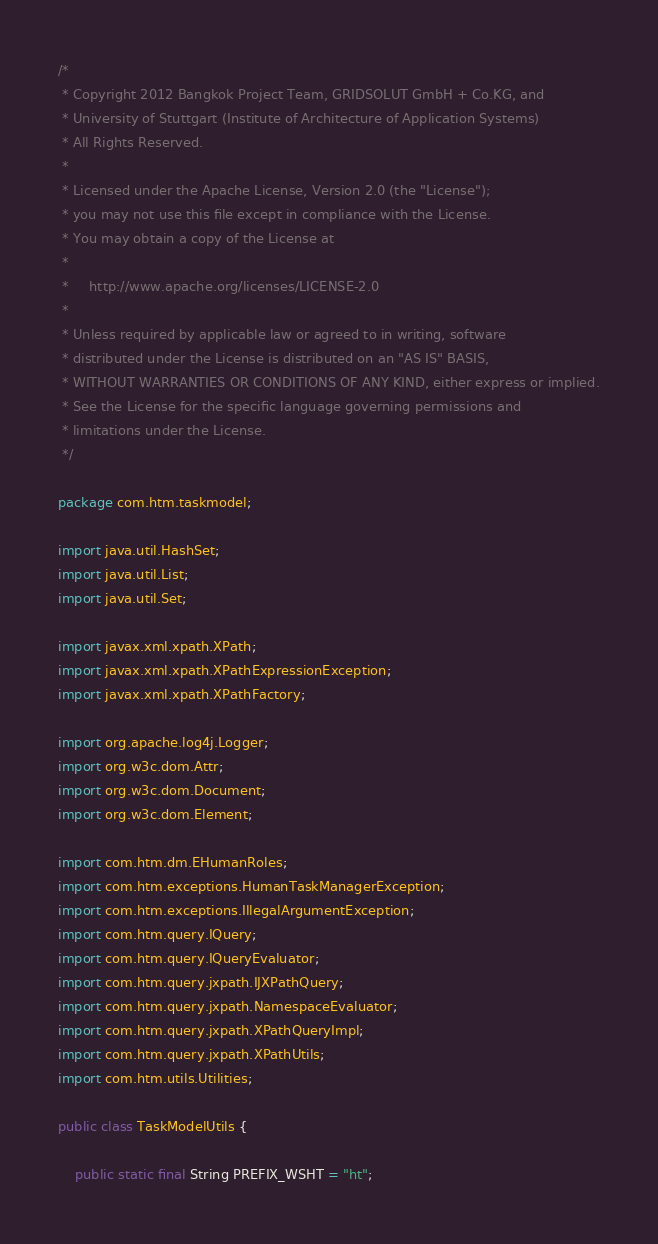Convert code to text. <code><loc_0><loc_0><loc_500><loc_500><_Java_>/*
 * Copyright 2012 Bangkok Project Team, GRIDSOLUT GmbH + Co.KG, and
 * University of Stuttgart (Institute of Architecture of Application Systems)
 * All Rights Reserved.
 *
 * Licensed under the Apache License, Version 2.0 (the "License");
 * you may not use this file except in compliance with the License.
 * You may obtain a copy of the License at
 *
 *     http://www.apache.org/licenses/LICENSE-2.0
 *
 * Unless required by applicable law or agreed to in writing, software
 * distributed under the License is distributed on an "AS IS" BASIS,
 * WITHOUT WARRANTIES OR CONDITIONS OF ANY KIND, either express or implied.
 * See the License for the specific language governing permissions and
 * limitations under the License.
 */

package com.htm.taskmodel;

import java.util.HashSet;
import java.util.List;
import java.util.Set;

import javax.xml.xpath.XPath;
import javax.xml.xpath.XPathExpressionException;
import javax.xml.xpath.XPathFactory;

import org.apache.log4j.Logger;
import org.w3c.dom.Attr;
import org.w3c.dom.Document;
import org.w3c.dom.Element;

import com.htm.dm.EHumanRoles;
import com.htm.exceptions.HumanTaskManagerException;
import com.htm.exceptions.IllegalArgumentException;
import com.htm.query.IQuery;
import com.htm.query.IQueryEvaluator;
import com.htm.query.jxpath.IJXPathQuery;
import com.htm.query.jxpath.NamespaceEvaluator;
import com.htm.query.jxpath.XPathQueryImpl;
import com.htm.query.jxpath.XPathUtils;
import com.htm.utils.Utilities;

public class TaskModelUtils {

    public static final String PREFIX_WSHT = "ht";
</code> 